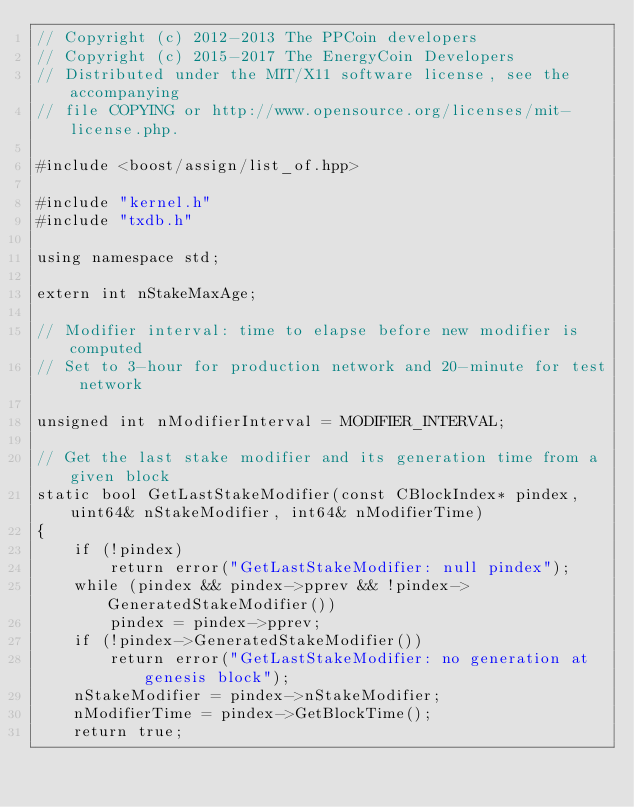<code> <loc_0><loc_0><loc_500><loc_500><_C++_>// Copyright (c) 2012-2013 The PPCoin developers
// Copyright (c) 2015-2017 The EnergyCoin Developers
// Distributed under the MIT/X11 software license, see the accompanying
// file COPYING or http://www.opensource.org/licenses/mit-license.php.

#include <boost/assign/list_of.hpp>

#include "kernel.h"
#include "txdb.h"

using namespace std;

extern int nStakeMaxAge;

// Modifier interval: time to elapse before new modifier is computed
// Set to 3-hour for production network and 20-minute for test network

unsigned int nModifierInterval = MODIFIER_INTERVAL;

// Get the last stake modifier and its generation time from a given block
static bool GetLastStakeModifier(const CBlockIndex* pindex, uint64& nStakeModifier, int64& nModifierTime)
{
    if (!pindex)
        return error("GetLastStakeModifier: null pindex");
    while (pindex && pindex->pprev && !pindex->GeneratedStakeModifier())
        pindex = pindex->pprev;
    if (!pindex->GeneratedStakeModifier())
        return error("GetLastStakeModifier: no generation at genesis block");
    nStakeModifier = pindex->nStakeModifier;
    nModifierTime = pindex->GetBlockTime();
    return true;</code> 